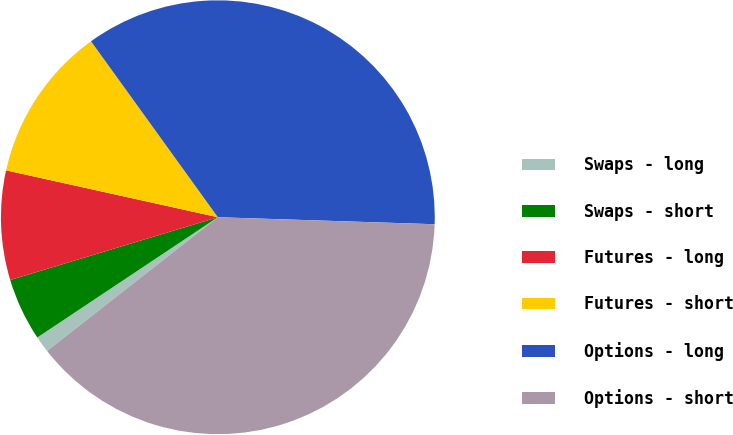Convert chart. <chart><loc_0><loc_0><loc_500><loc_500><pie_chart><fcel>Swaps - long<fcel>Swaps - short<fcel>Futures - long<fcel>Futures - short<fcel>Options - long<fcel>Options - short<nl><fcel>1.22%<fcel>4.68%<fcel>8.14%<fcel>11.59%<fcel>35.45%<fcel>38.91%<nl></chart> 